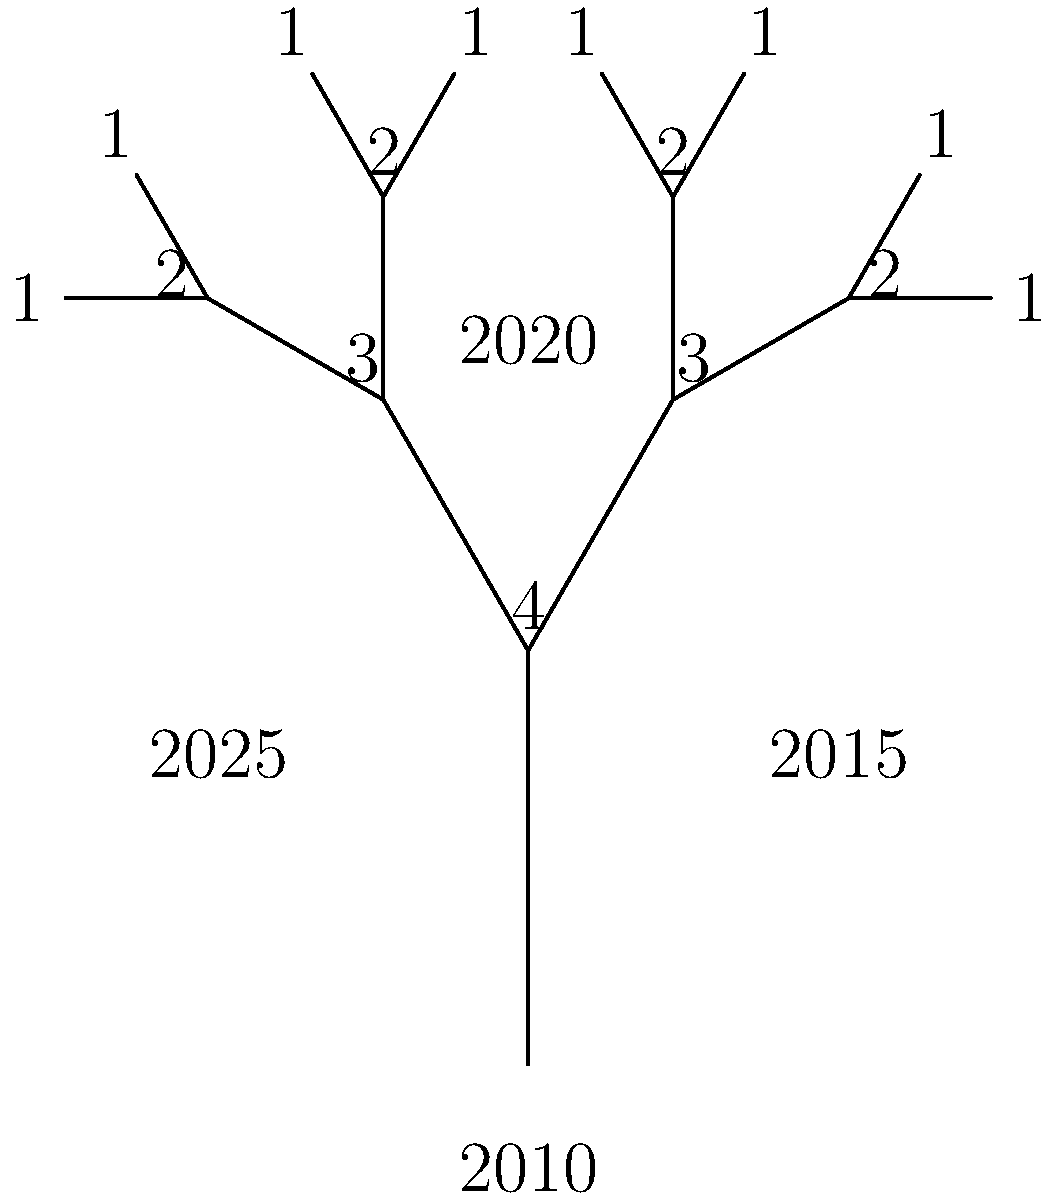The tree diagram represents the growth of Croatian confectionery companies from 2010 to 2025. Each level of the tree corresponds to a 5-year period, and the number at each node represents the number of major confectionery companies. Based on this diagram, what is the compound annual growth rate (CAGR) of the number of major confectionery companies in Croatia between 2010 and 2025? To calculate the Compound Annual Growth Rate (CAGR), we need to follow these steps:

1. Identify the initial and final values:
   Initial value (2010): 1 company
   Final value (2025): 4 companies

2. Determine the time period:
   2025 - 2010 = 15 years

3. Use the CAGR formula:
   $CAGR = (Final Value / Initial Value)^{(1/n)} - 1$
   Where n is the number of years

4. Plug in the values:
   $CAGR = (4 / 1)^{(1/15)} - 1$

5. Calculate:
   $CAGR = 1.41^{(1/15)} - 1$
   $CAGR = 1.0991 - 1$
   $CAGR = 0.0991$

6. Convert to percentage:
   $CAGR = 9.91\%$

Therefore, the compound annual growth rate of major confectionery companies in Croatia between 2010 and 2025 is approximately 9.91%.
Answer: 9.91% 